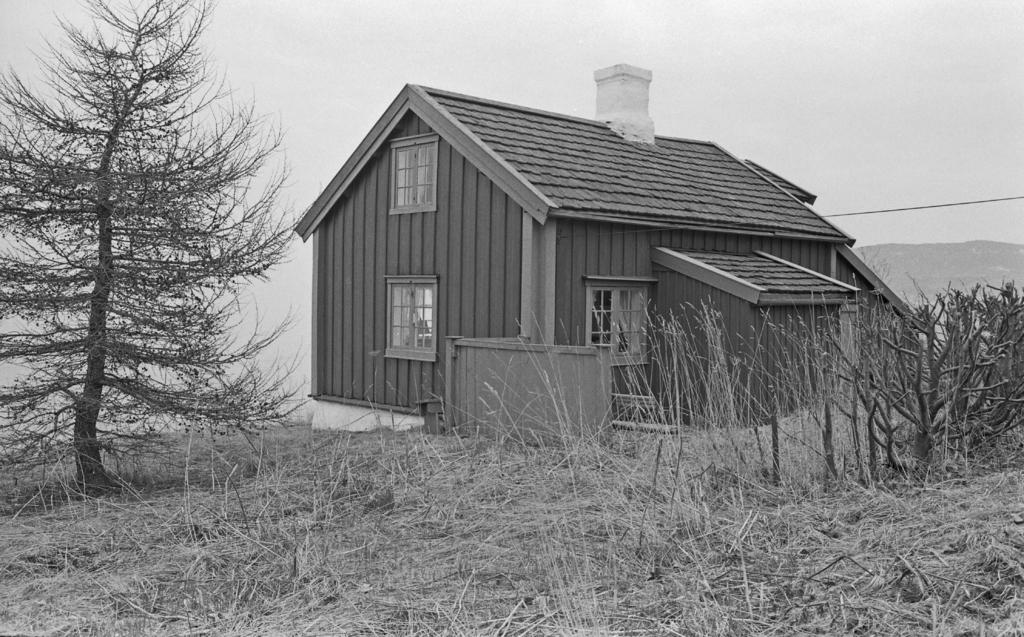What is the color scheme of the image? The image is black and white. What can be seen in the image besides the color scheme? There are branches, a tree, a hill, a shelter, grass, and the sky visible in the image. What type of spark can be seen coming from the tree in the image? There is no spark present in the image; it is a black and white image of a tree, hill, shelter, and grass. 